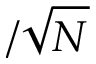Convert formula to latex. <formula><loc_0><loc_0><loc_500><loc_500>/ \sqrt { N }</formula> 